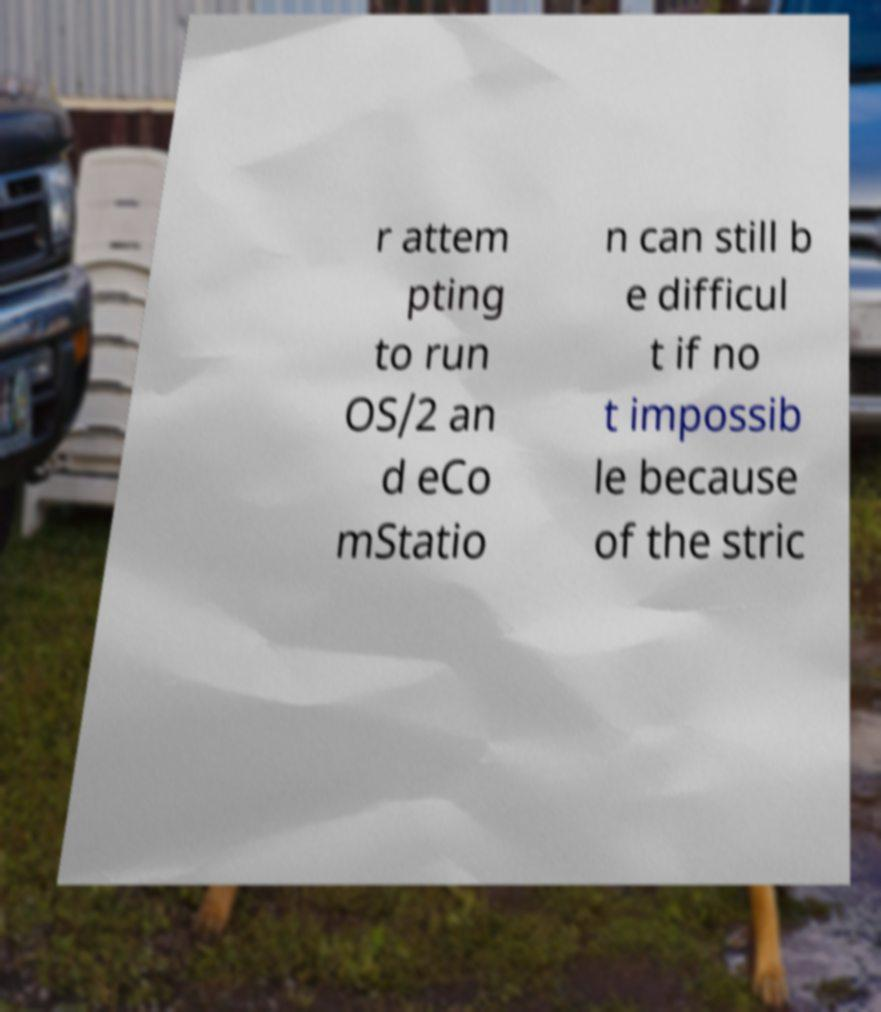Please read and relay the text visible in this image. What does it say? r attem pting to run OS/2 an d eCo mStatio n can still b e difficul t if no t impossib le because of the stric 